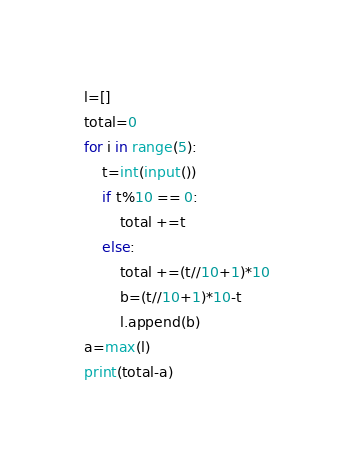Convert code to text. <code><loc_0><loc_0><loc_500><loc_500><_Python_>l=[]
total=0
for i in range(5):
    t=int(input())
    if t%10 == 0:
        total +=t
    else:    
        total +=(t//10+1)*10
        b=(t//10+1)*10-t
        l.append(b)
a=max(l)
print(total-a)</code> 